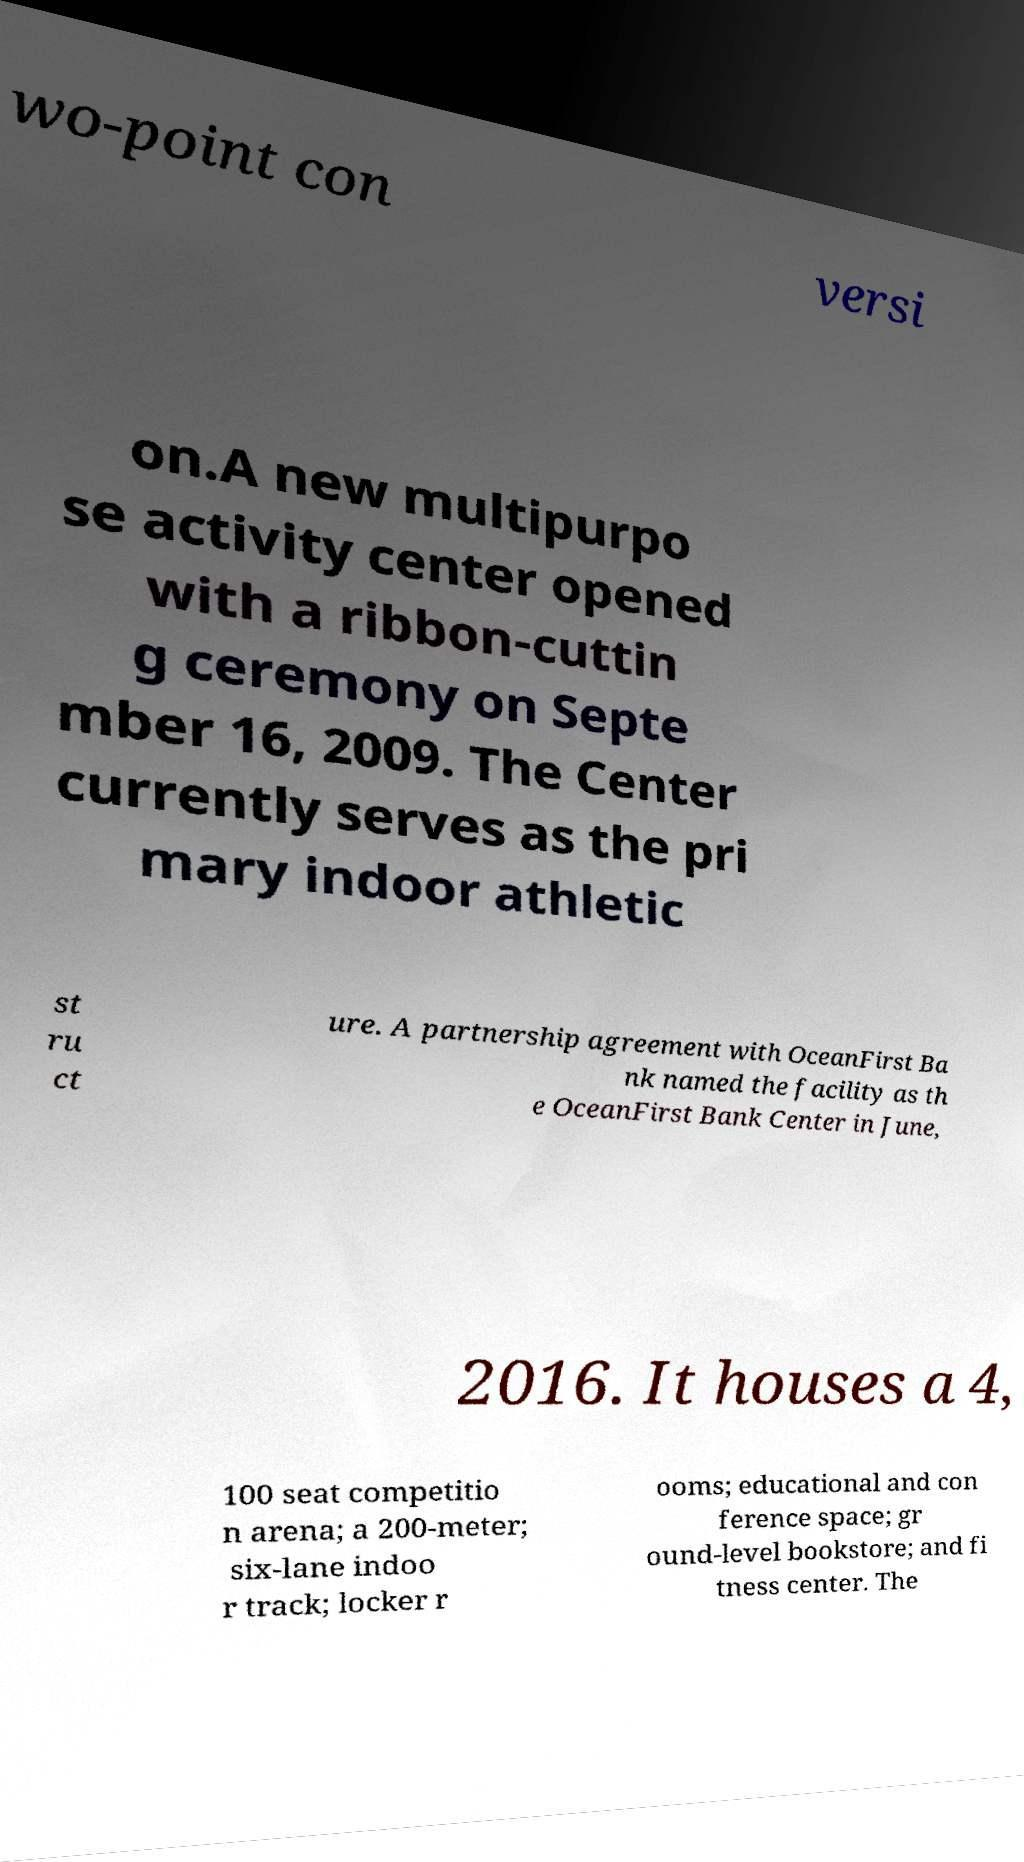There's text embedded in this image that I need extracted. Can you transcribe it verbatim? wo-point con versi on.A new multipurpo se activity center opened with a ribbon-cuttin g ceremony on Septe mber 16, 2009. The Center currently serves as the pri mary indoor athletic st ru ct ure. A partnership agreement with OceanFirst Ba nk named the facility as th e OceanFirst Bank Center in June, 2016. It houses a 4, 100 seat competitio n arena; a 200-meter; six-lane indoo r track; locker r ooms; educational and con ference space; gr ound-level bookstore; and fi tness center. The 